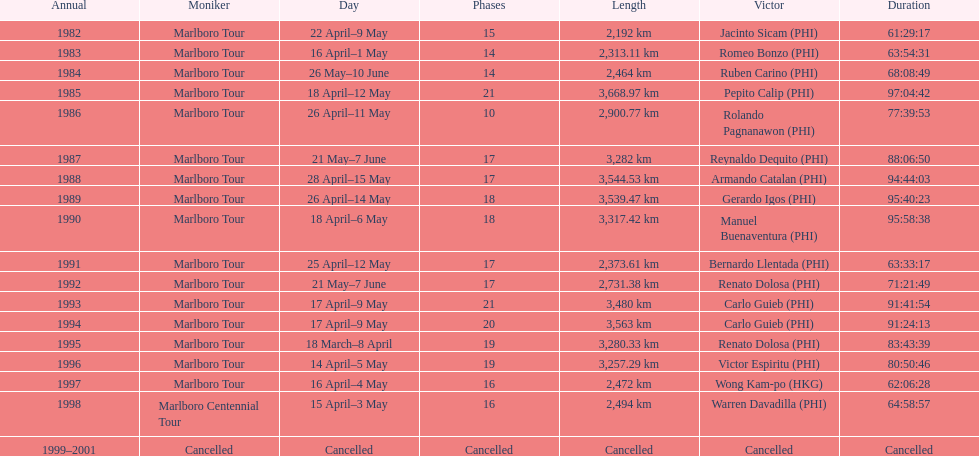Write the full table. {'header': ['Annual', 'Moniker', 'Day', 'Phases', 'Length', 'Victor', 'Duration'], 'rows': [['1982', 'Marlboro Tour', '22 April–9 May', '15', '2,192\xa0km', 'Jacinto Sicam\xa0(PHI)', '61:29:17'], ['1983', 'Marlboro Tour', '16 April–1 May', '14', '2,313.11\xa0km', 'Romeo Bonzo\xa0(PHI)', '63:54:31'], ['1984', 'Marlboro Tour', '26 May–10 June', '14', '2,464\xa0km', 'Ruben Carino\xa0(PHI)', '68:08:49'], ['1985', 'Marlboro Tour', '18 April–12 May', '21', '3,668.97\xa0km', 'Pepito Calip\xa0(PHI)', '97:04:42'], ['1986', 'Marlboro Tour', '26 April–11 May', '10', '2,900.77\xa0km', 'Rolando Pagnanawon\xa0(PHI)', '77:39:53'], ['1987', 'Marlboro Tour', '21 May–7 June', '17', '3,282\xa0km', 'Reynaldo Dequito\xa0(PHI)', '88:06:50'], ['1988', 'Marlboro Tour', '28 April–15 May', '17', '3,544.53\xa0km', 'Armando Catalan\xa0(PHI)', '94:44:03'], ['1989', 'Marlboro Tour', '26 April–14 May', '18', '3,539.47\xa0km', 'Gerardo Igos\xa0(PHI)', '95:40:23'], ['1990', 'Marlboro Tour', '18 April–6 May', '18', '3,317.42\xa0km', 'Manuel Buenaventura\xa0(PHI)', '95:58:38'], ['1991', 'Marlboro Tour', '25 April–12 May', '17', '2,373.61\xa0km', 'Bernardo Llentada\xa0(PHI)', '63:33:17'], ['1992', 'Marlboro Tour', '21 May–7 June', '17', '2,731.38\xa0km', 'Renato Dolosa\xa0(PHI)', '71:21:49'], ['1993', 'Marlboro Tour', '17 April–9 May', '21', '3,480\xa0km', 'Carlo Guieb\xa0(PHI)', '91:41:54'], ['1994', 'Marlboro Tour', '17 April–9 May', '20', '3,563\xa0km', 'Carlo Guieb\xa0(PHI)', '91:24:13'], ['1995', 'Marlboro Tour', '18 March–8 April', '19', '3,280.33\xa0km', 'Renato Dolosa\xa0(PHI)', '83:43:39'], ['1996', 'Marlboro Tour', '14 April–5 May', '19', '3,257.29\xa0km', 'Victor Espiritu\xa0(PHI)', '80:50:46'], ['1997', 'Marlboro Tour', '16 April–4 May', '16', '2,472\xa0km', 'Wong Kam-po\xa0(HKG)', '62:06:28'], ['1998', 'Marlboro Centennial Tour', '15 April–3 May', '16', '2,494\xa0km', 'Warren Davadilla\xa0(PHI)', '64:58:57'], ['1999–2001', 'Cancelled', 'Cancelled', 'Cancelled', 'Cancelled', 'Cancelled', 'Cancelled']]} Who were all of the winners? Jacinto Sicam (PHI), Romeo Bonzo (PHI), Ruben Carino (PHI), Pepito Calip (PHI), Rolando Pagnanawon (PHI), Reynaldo Dequito (PHI), Armando Catalan (PHI), Gerardo Igos (PHI), Manuel Buenaventura (PHI), Bernardo Llentada (PHI), Renato Dolosa (PHI), Carlo Guieb (PHI), Carlo Guieb (PHI), Renato Dolosa (PHI), Victor Espiritu (PHI), Wong Kam-po (HKG), Warren Davadilla (PHI), Cancelled. When did they compete? 1982, 1983, 1984, 1985, 1986, 1987, 1988, 1989, 1990, 1991, 1992, 1993, 1994, 1995, 1996, 1997, 1998, 1999–2001. What were their finishing times? 61:29:17, 63:54:31, 68:08:49, 97:04:42, 77:39:53, 88:06:50, 94:44:03, 95:40:23, 95:58:38, 63:33:17, 71:21:49, 91:41:54, 91:24:13, 83:43:39, 80:50:46, 62:06:28, 64:58:57, Cancelled. And who won during 1998? Warren Davadilla (PHI). What was his time? 64:58:57. 